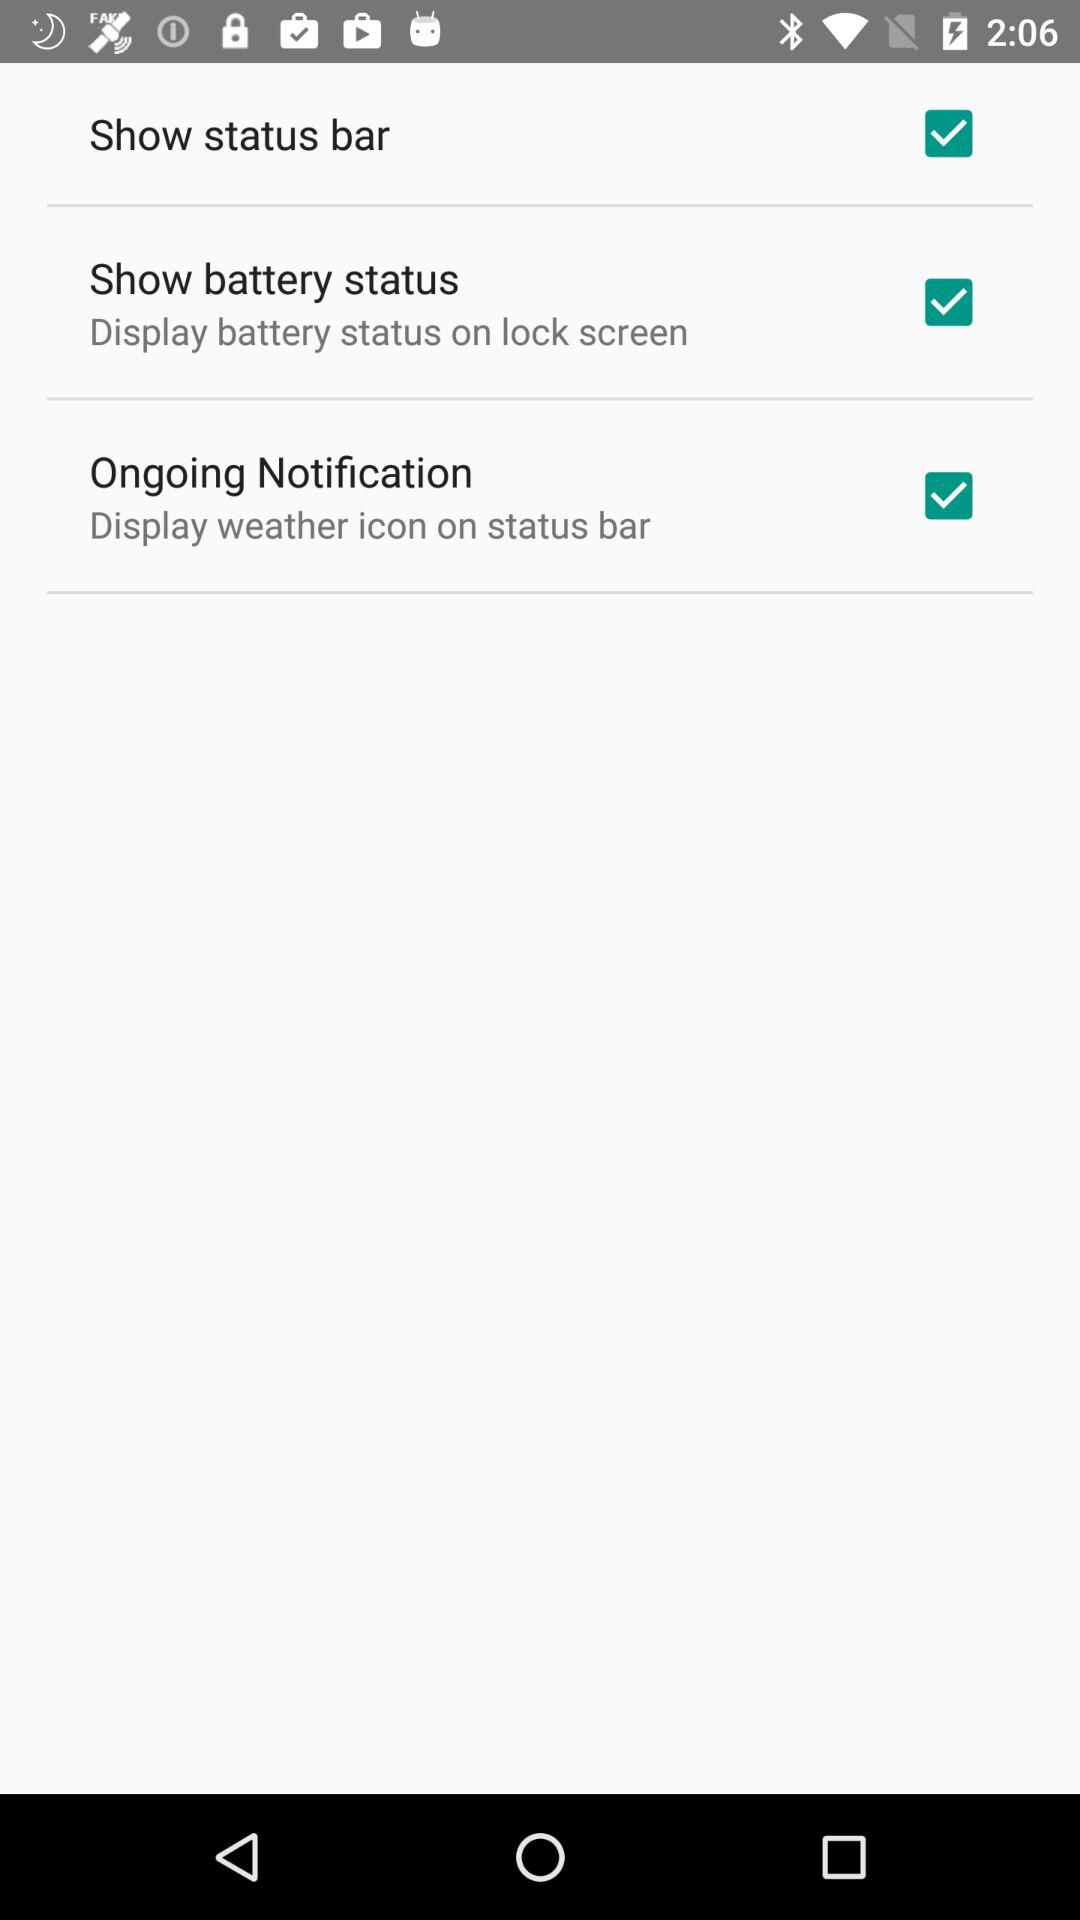What is the status of "Show status bar"? The status of "Show status bar" is "on". 